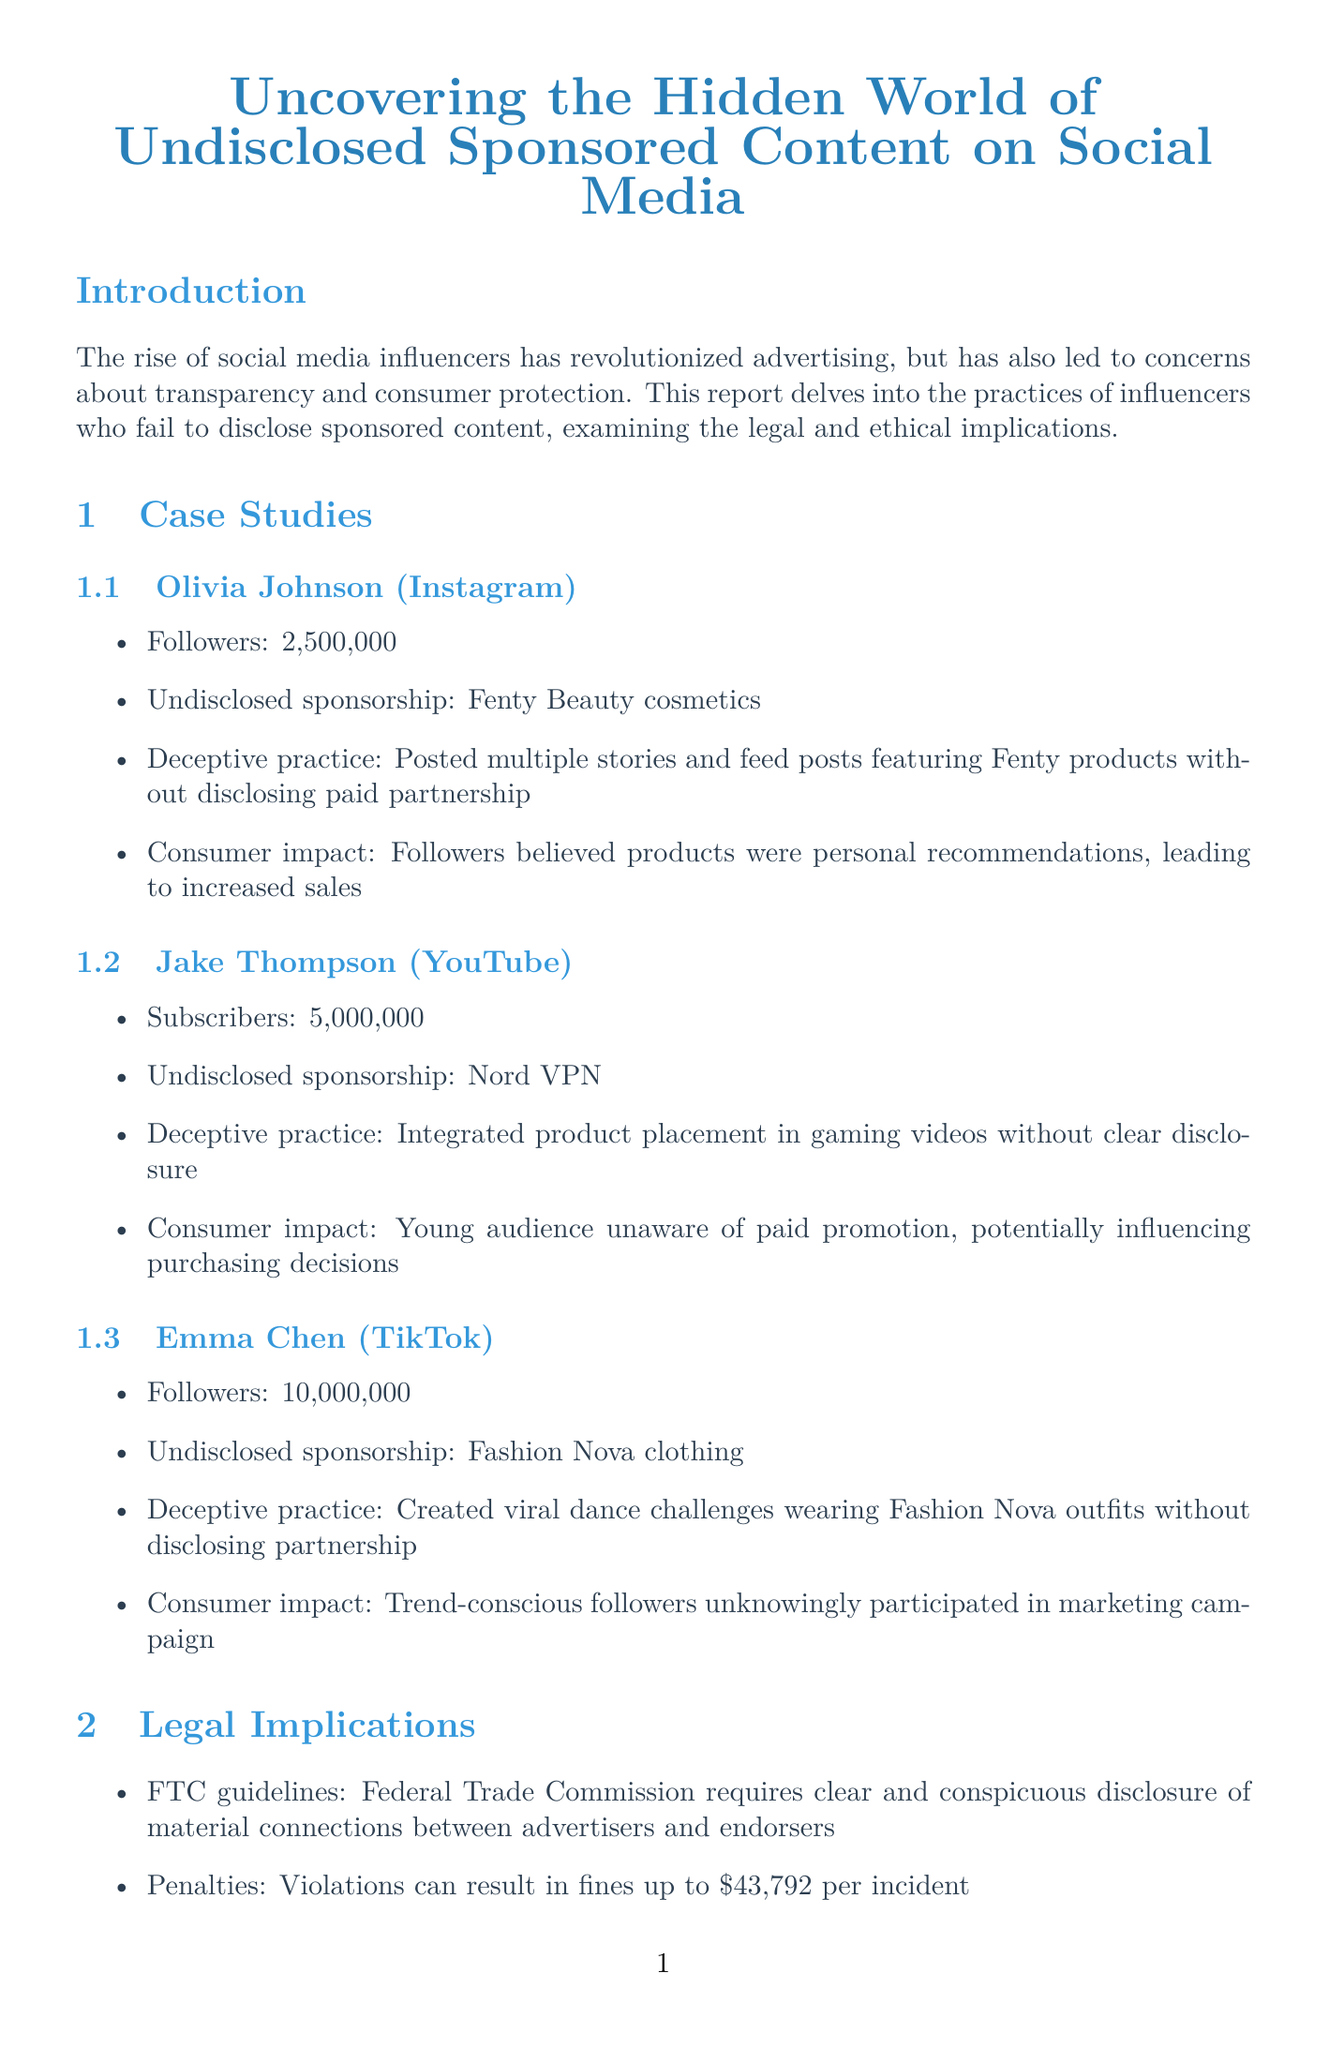What is the title of the report? The title is located at the top of the document, and it is "Uncovering the Hidden World of Undisclosed Sponsored Content on Social Media."
Answer: Uncovering the Hidden World of Undisclosed Sponsored Content on Social Media How many followers does Olivia Johnson have? Olivia Johnson's follower count is explicitly listed as 2,500,000.
Answer: 2,500,000 What is the penalty for violating FTC guidelines? The penalties are mentioned under legal implications and state that violations can result in fines up to $43,792 per incident.
Answer: $43,792 Which influencer promoted Fashion Nova clothing? The document identifies Emma Chen as the influencer who unduly promoted Fashion Nova clothing in her TikTok videos.
Answer: Emma Chen What percentage of Americans can't consistently identify sponsored content? The survey data indicates that 64% of Americans cannot consistently identify sponsored content.
Answer: 64% What is a recent enforcement action taken by the FTC mentioned in the report? The report outlines the FTC's settlement with Teami, LLC as a recent enforcement action for deceptive influencer marketing practices.
Answer: FTC's settlement with Teami, LLC What initiative is being launched by consumer advocacy groups? The document mentions that consumer advocacy groups are launching social media literacy campaigns aimed at increasing consumer awareness.
Answer: Social media literacy campaigns Who is quoted regarding consumer protection challenges in digital media? Dr. Sarah Martinez is quoted in the report discussing consumer protection challenges in the digital age.
Answer: Dr. Sarah Martinez 